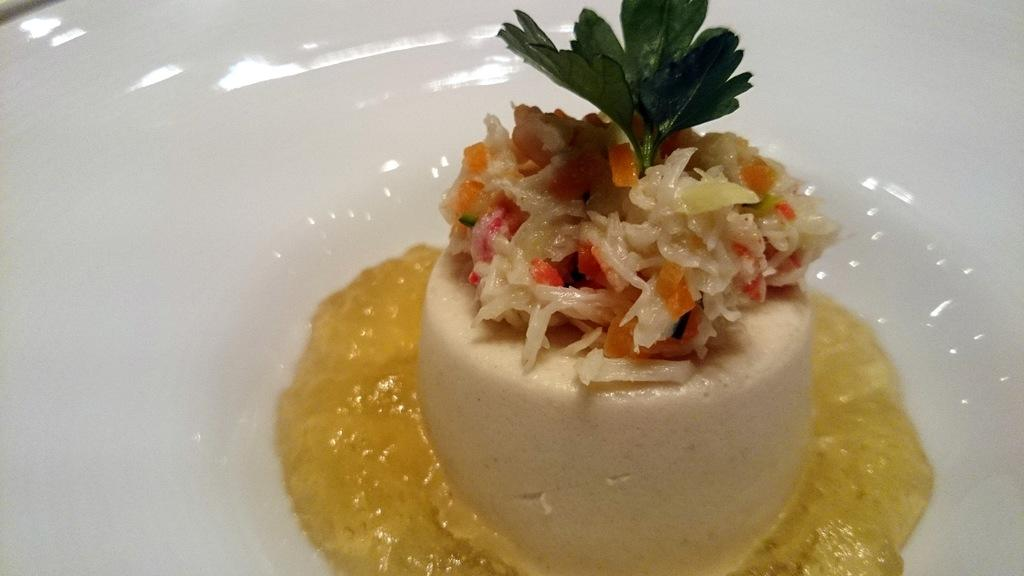What object is present on the plate in the image? There is a food item on the plate in the image. Can you describe any additional elements in the image? Yes, there is a coriander leaf and sauce in the image. How many kittens are playing with a comb in the image? There are no kittens or combs present in the image. 